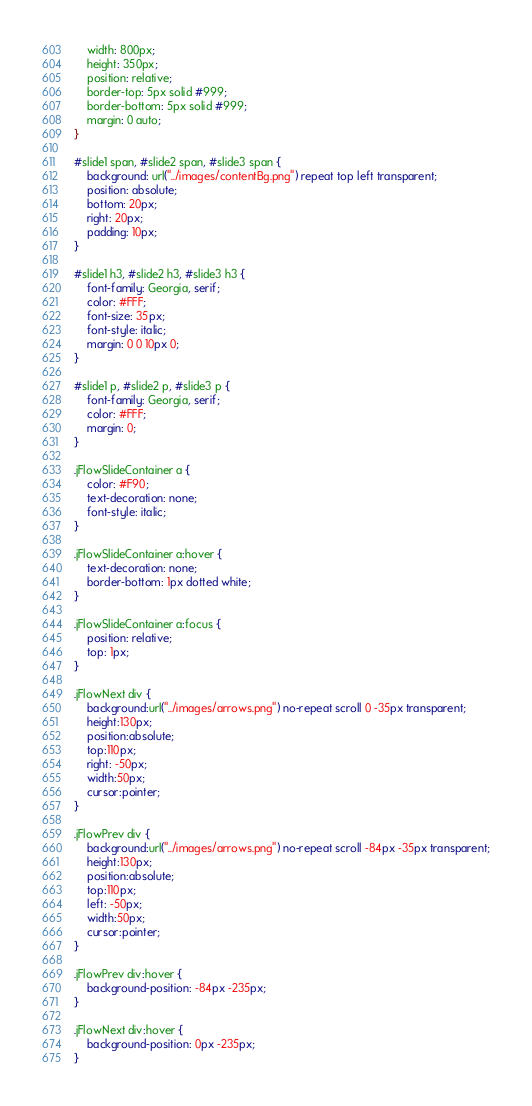<code> <loc_0><loc_0><loc_500><loc_500><_CSS_>	width: 800px;
	height: 350px;
	position: relative;
	border-top: 5px solid #999;
	border-bottom: 5px solid #999;
	margin: 0 auto;
}

#slide1 span, #slide2 span, #slide3 span {
	background: url("../images/contentBg.png") repeat top left transparent;
	position: absolute;
	bottom: 20px;
	right: 20px;
	padding: 10px;
}

#slide1 h3, #slide2 h3, #slide3 h3 {
	font-family: Georgia, serif;
	color: #FFF;
	font-size: 35px;
	font-style: italic;
	margin: 0 0 10px 0;
}

#slide1 p, #slide2 p, #slide3 p {
	font-family: Georgia, serif;
	color: #FFF;	
	margin: 0;
}

.jFlowSlideContainer a {
	color: #F90;
	text-decoration: none;
	font-style: italic;
}

.jFlowSlideContainer a:hover {
	text-decoration: none;
	border-bottom: 1px dotted white;
}

.jFlowSlideContainer a:focus {
	position: relative;
	top: 1px;
}

.jFlowNext div {
	background:url("../images/arrows.png") no-repeat scroll 0 -35px transparent;
	height:130px;
	position:absolute;
	top:110px;
	right: -50px;
	width:50px;
	cursor:pointer;
}

.jFlowPrev div {
	background:url("../images/arrows.png") no-repeat scroll -84px -35px transparent;
	height:130px;
	position:absolute;
	top:110px;
	left: -50px;
	width:50px;
	cursor:pointer;
}

.jFlowPrev div:hover {
	background-position: -84px -235px;
}

.jFlowNext div:hover {
	background-position: 0px -235px;
}
</code> 